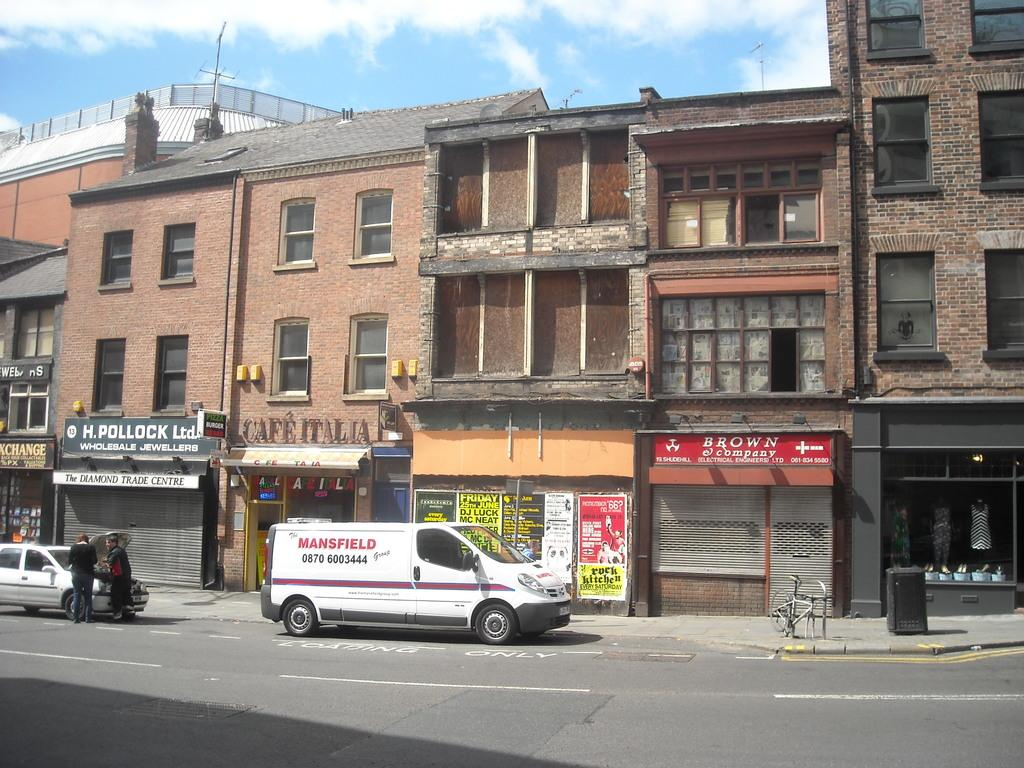What type of structures can be seen in the image? There are buildings in the image. What is happening on the road at the bottom of the image? There are vehicles on the road at the bottom of the image. Can you describe the people on the left side of the image? There are two people on the left side of the image. What can be seen in the background of the image? There is sky visible in the background of the image. What word is being spoken by the person on the left side of the image? There is no indication of any spoken words in the image, so it cannot be determined which word might be spoken. Is the person on the left side of the image the brother of the person on the right side of the image? There is no information about any relationships between the people in the image, so it cannot be determined if they are siblings. 